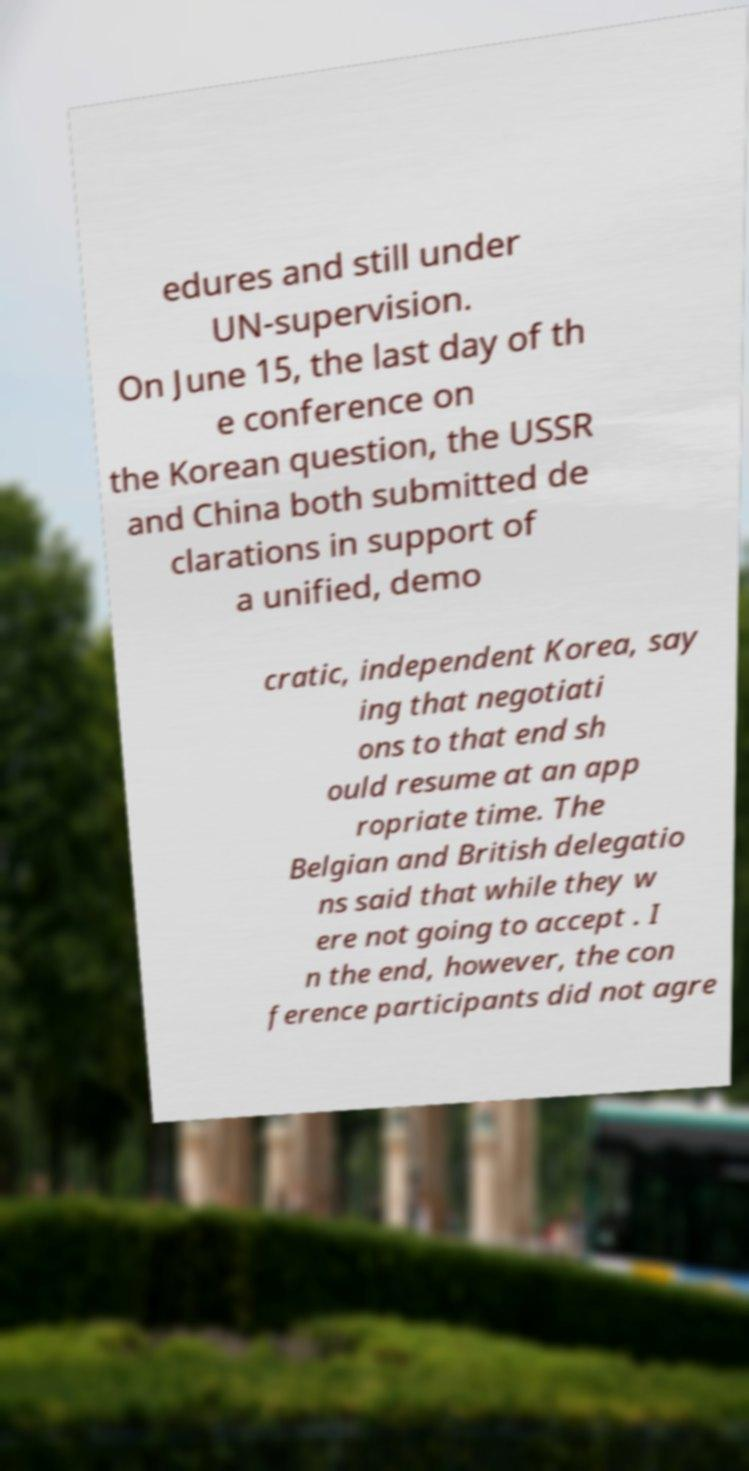What messages or text are displayed in this image? I need them in a readable, typed format. edures and still under UN-supervision. On June 15, the last day of th e conference on the Korean question, the USSR and China both submitted de clarations in support of a unified, demo cratic, independent Korea, say ing that negotiati ons to that end sh ould resume at an app ropriate time. The Belgian and British delegatio ns said that while they w ere not going to accept . I n the end, however, the con ference participants did not agre 